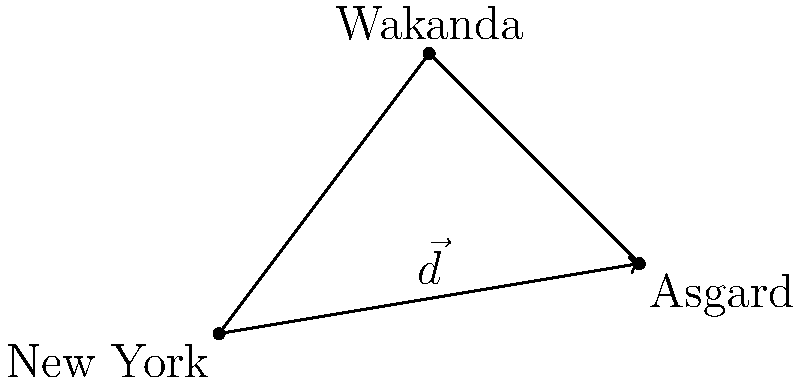In the MCU, Doctor Strange teleports from New York to Asgard. Given that New York is at coordinates (0,0), Wakanda at (3,4), and Asgard at (6,1), what is the displacement vector $\vec{d}$ from New York to Asgard? To find the displacement vector $\vec{d}$ from New York to Asgard, we need to follow these steps:

1. Identify the coordinates:
   New York: $(0,0)$
   Asgard: $(6,1)$

2. Calculate the displacement in the x-direction:
   $\Delta x = 6 - 0 = 6$

3. Calculate the displacement in the y-direction:
   $\Delta y = 1 - 0 = 1$

4. Express the displacement vector in component form:
   $\vec{d} = \langle \Delta x, \Delta y \rangle = \langle 6, 1 \rangle$

5. Alternatively, we can express it in magnitude and direction form:
   Magnitude: $|\vec{d}| = \sqrt{6^2 + 1^2} = \sqrt{37}$
   Direction: $\theta = \tan^{-1}(\frac{1}{6})$

However, the component form $\langle 6, 1 \rangle$ is the most concise representation of the displacement vector.
Answer: $\vec{d} = \langle 6, 1 \rangle$ 